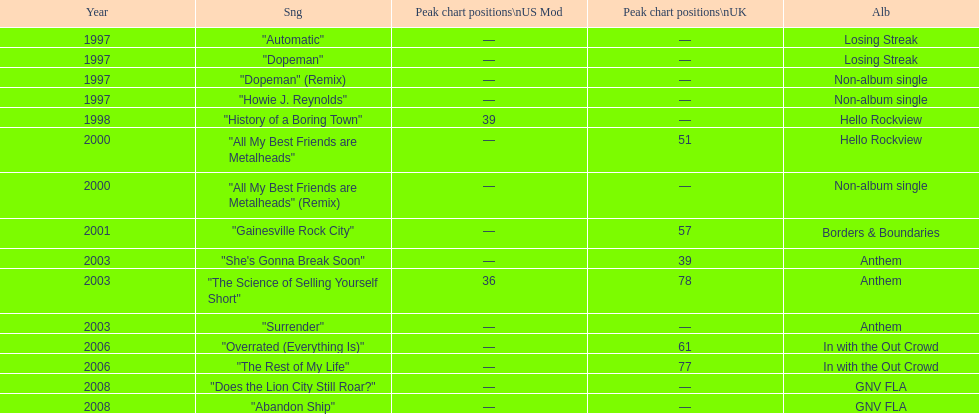What was the next single after "overrated (everything is)"? "The Rest of My Life". 